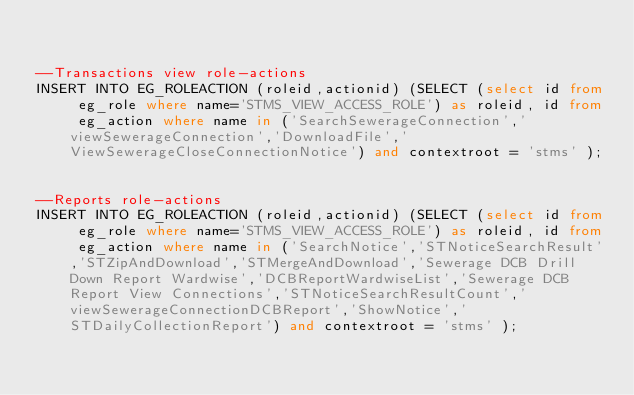Convert code to text. <code><loc_0><loc_0><loc_500><loc_500><_SQL_>

--Transactions view role-actions
INSERT INTO EG_ROLEACTION (roleid,actionid) (SELECT (select id from eg_role where name='STMS_VIEW_ACCESS_ROLE') as roleid, id from eg_action where name in ('SearchSewerageConnection','viewSewerageConnection','DownloadFile','ViewSewerageCloseConnectionNotice') and contextroot = 'stms' );


--Reports role-actions
INSERT INTO EG_ROLEACTION (roleid,actionid) (SELECT (select id from eg_role where name='STMS_VIEW_ACCESS_ROLE') as roleid, id from eg_action where name in ('SearchNotice','STNoticeSearchResult','STZipAndDownload','STMergeAndDownload','Sewerage DCB Drill Down Report Wardwise','DCBReportWardwiseList','Sewerage DCB Report View Connections','STNoticeSearchResultCount','viewSewerageConnectionDCBReport','ShowNotice','STDailyCollectionReport') and contextroot = 'stms' );
</code> 